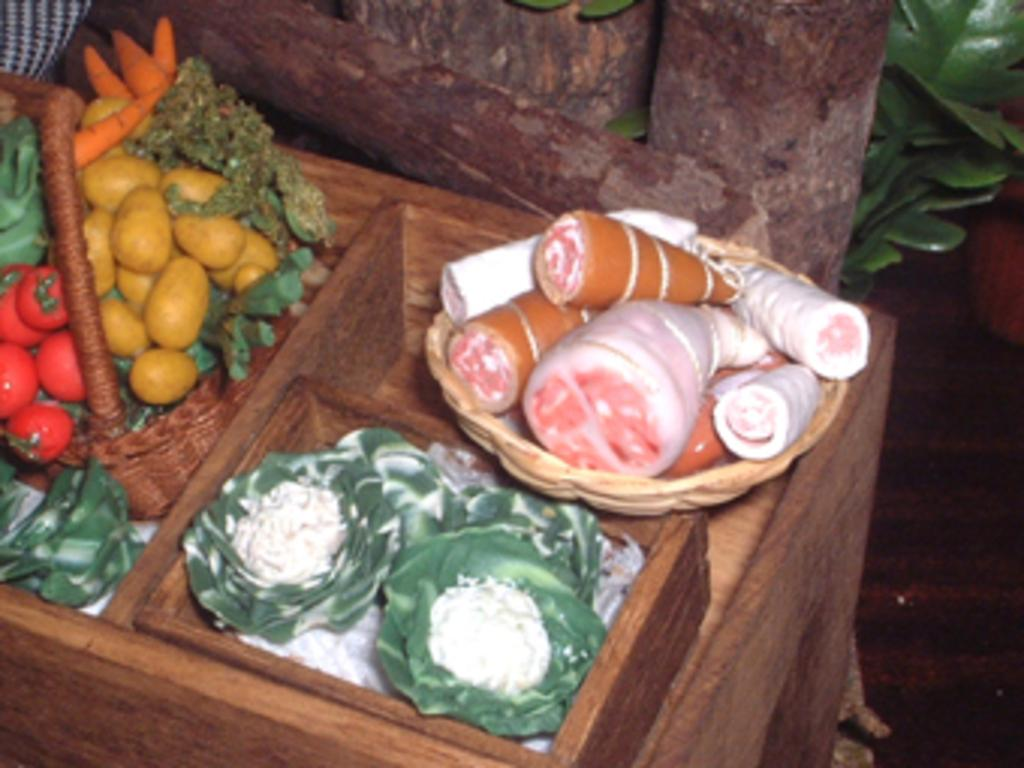What is in the basket that is visible in the image? There are vegetables in a basket in the image. What else can be seen on the wooden table in the image? There are also vegetables on the wooden table in the image. What is visible in the background of the image? There is a wall and a plant hire visible in the background of the image. What type of science experiment is being conducted with the vegetables in the image? There is no science experiment being conducted with the vegetables in the image; they are simply displayed in a basket and on a table. 